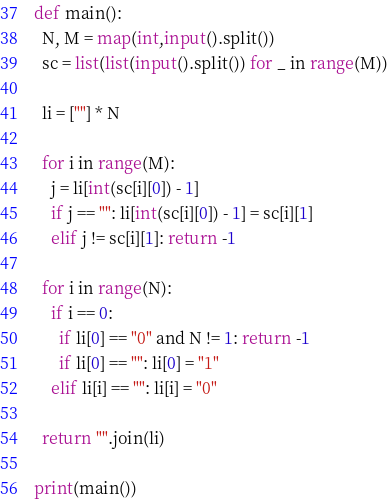<code> <loc_0><loc_0><loc_500><loc_500><_Python_>def main():
  N, M = map(int,input().split())
  sc = list(list(input().split()) for _ in range(M))

  li = [""] * N

  for i in range(M):
    j = li[int(sc[i][0]) - 1]
    if j == "": li[int(sc[i][0]) - 1] = sc[i][1]
    elif j != sc[i][1]: return -1

  for i in range(N):
    if i == 0:
      if li[0] == "0" and N != 1: return -1
      if li[0] == "": li[0] = "1"
    elif li[i] == "": li[i] = "0"

  return "".join(li)

print(main())</code> 